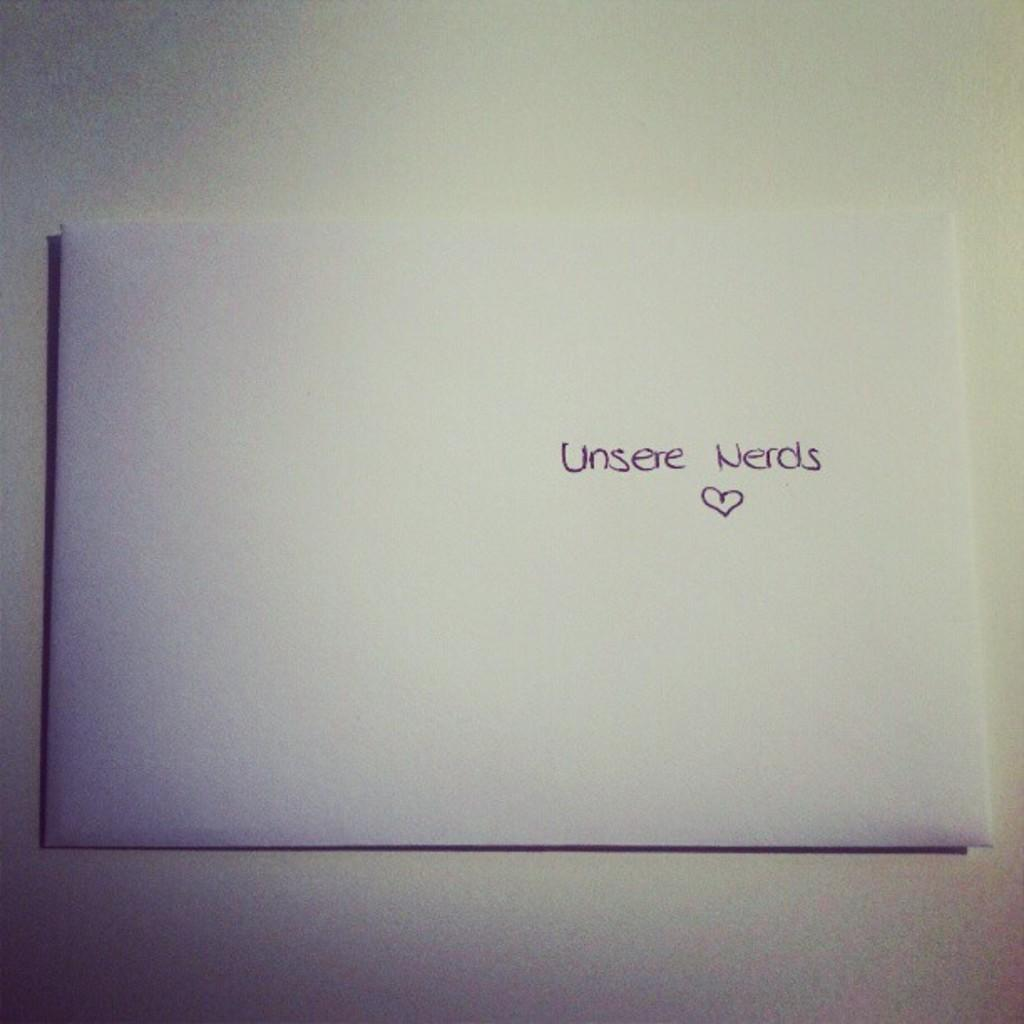<image>
Describe the image concisely. a white envelope with unsere nerds written in purple ink 